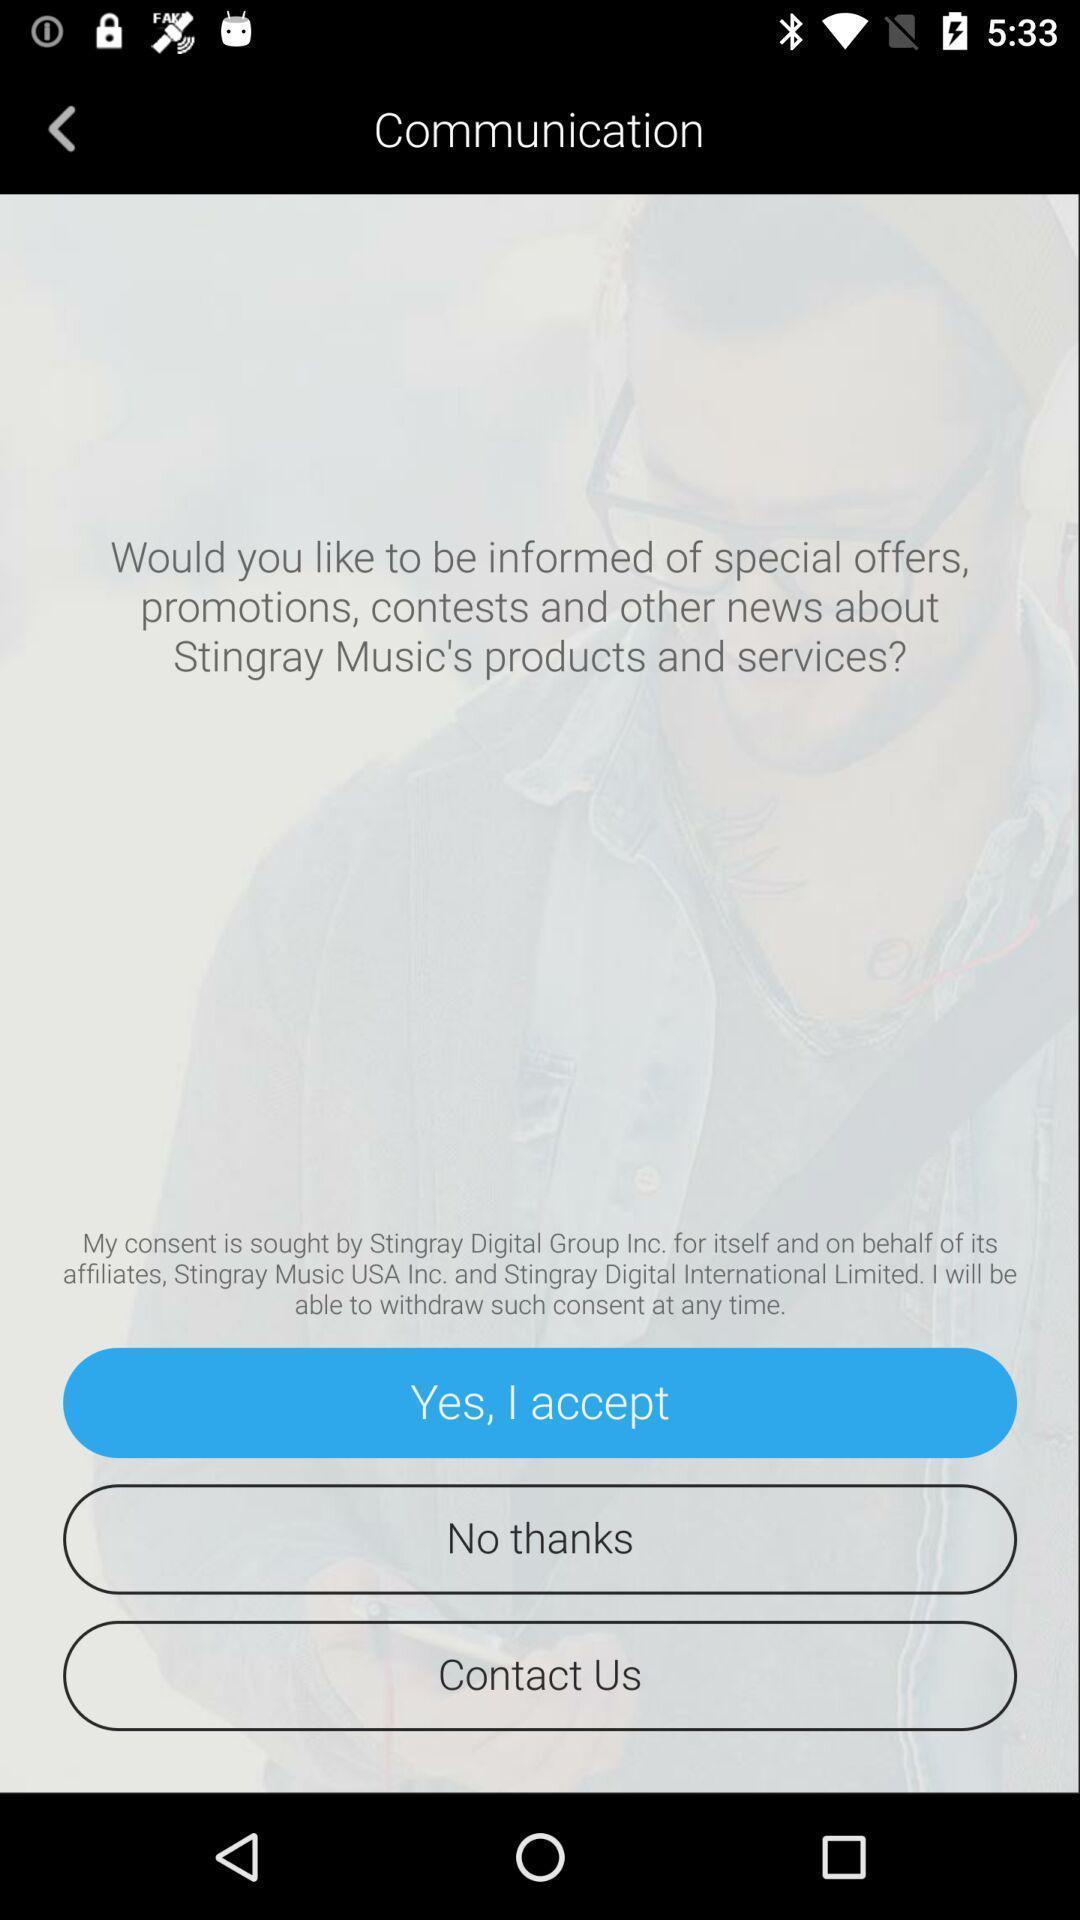Provide a detailed account of this screenshot. Screen shows communication details of a music app. 